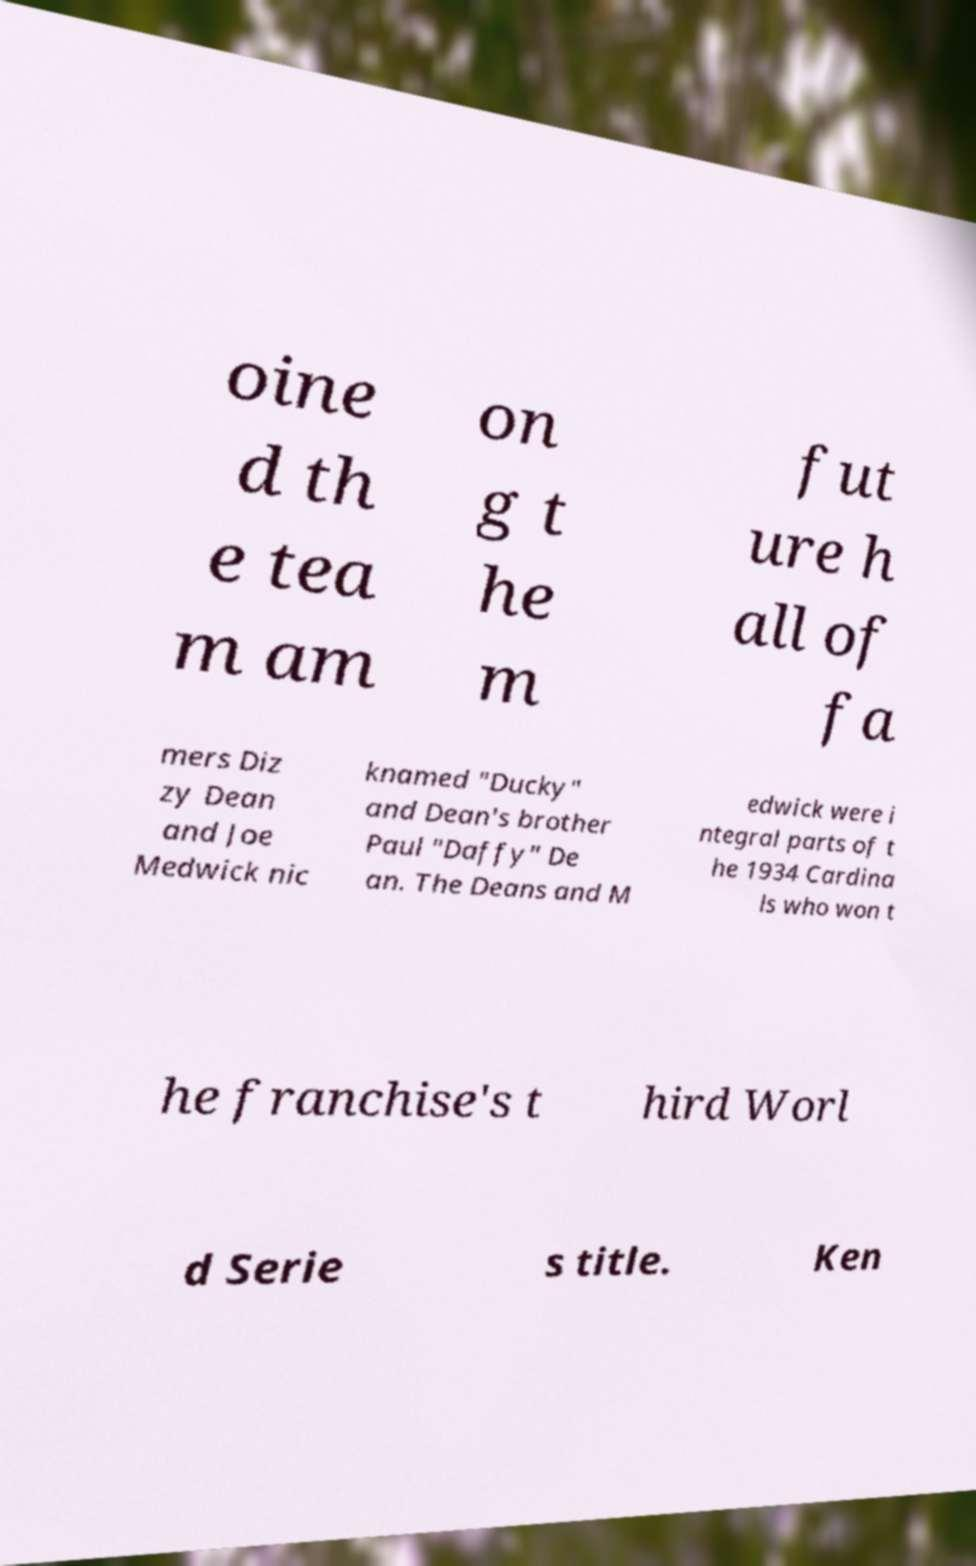Could you assist in decoding the text presented in this image and type it out clearly? oine d th e tea m am on g t he m fut ure h all of fa mers Diz zy Dean and Joe Medwick nic knamed "Ducky" and Dean's brother Paul "Daffy" De an. The Deans and M edwick were i ntegral parts of t he 1934 Cardina ls who won t he franchise's t hird Worl d Serie s title. Ken 